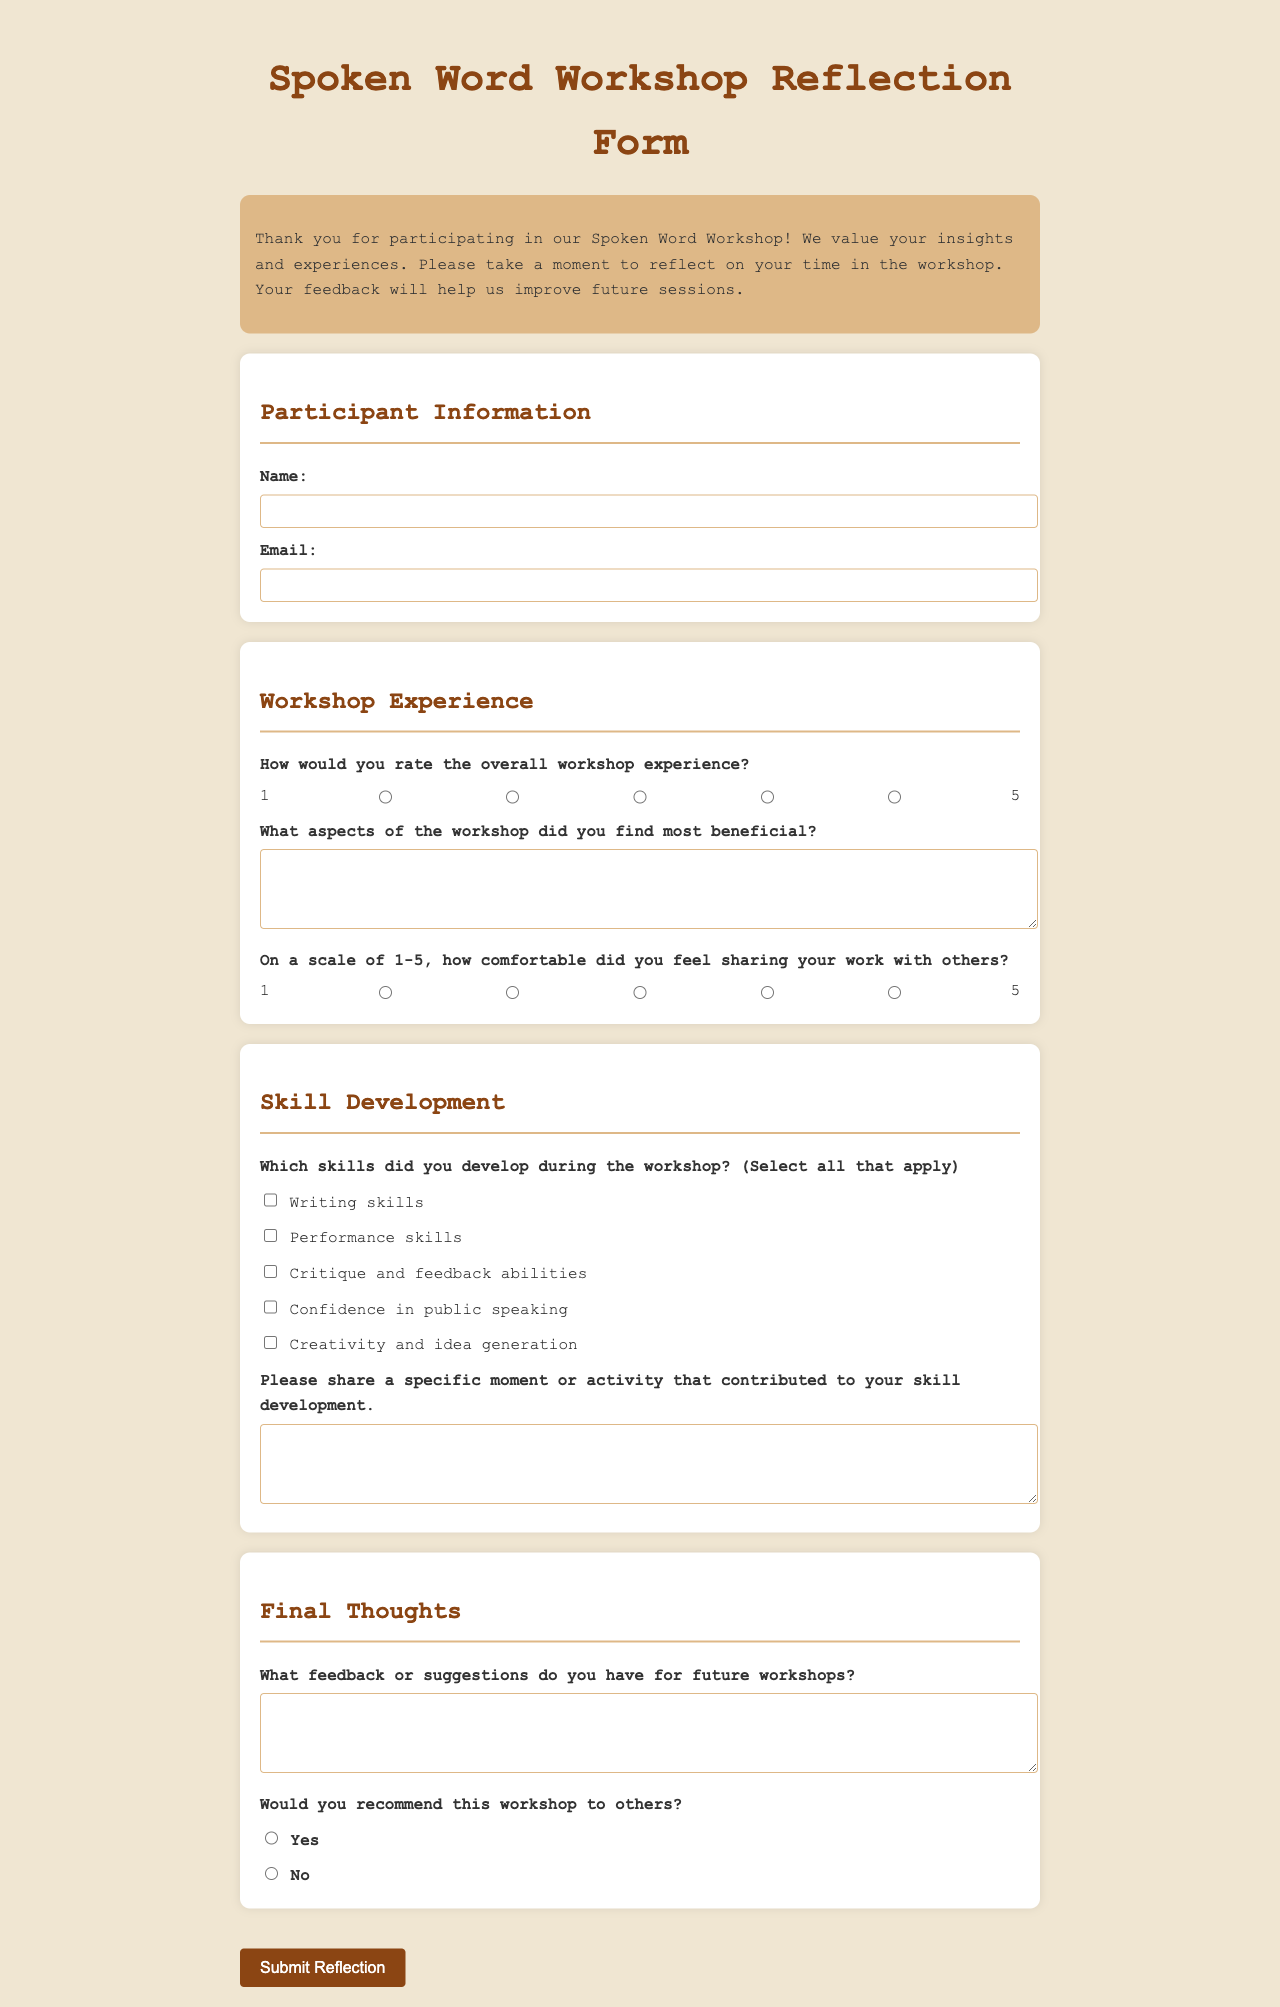What is the title of the form? The title appears at the top of the document and indicates the purpose of the form.
Answer: Spoken Word Workshop Reflection Form What are the colors used for the header? The header's colors are specifically chosen to convey a certain aesthetic appeal, described in the document.
Answer: #8b4513 How many aspects could participants select for skills developed? The document lists multiple options for participants to choose from regarding their skill development.
Answer: Five What is the required comfort level rating scale? The scale for rating comfort level is specified, indicating how participants should assess their experience.
Answer: 1 to 5 What are participants asked to provide in the feedback section? This section requests participants to share their thoughts on future improvements for the workshop.
Answer: Suggestions How is the workshop experience overall rated? The document indicates a method for participants to evaluate their workshop experience.
Answer: 1 to 5 What is included in the introduction section? This part of the document provides context and thanks participants for their involvement.
Answer: Brief thank you note What is the submission button labeled as? The button at the end of the form encourages participants to submit their reflections.
Answer: Submit Reflection 